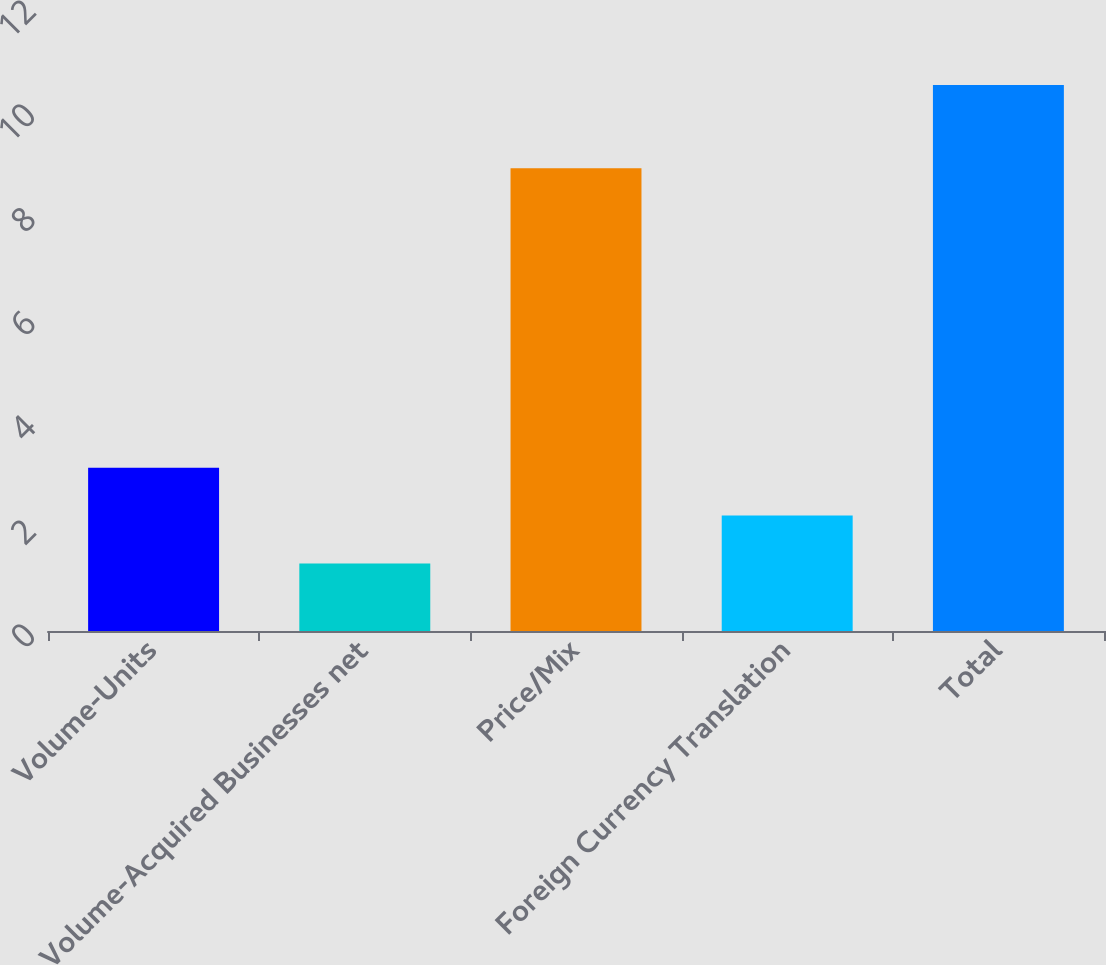Convert chart. <chart><loc_0><loc_0><loc_500><loc_500><bar_chart><fcel>Volume-Units<fcel>Volume-Acquired Businesses net<fcel>Price/Mix<fcel>Foreign Currency Translation<fcel>Total<nl><fcel>3.14<fcel>1.3<fcel>8.9<fcel>2.22<fcel>10.5<nl></chart> 